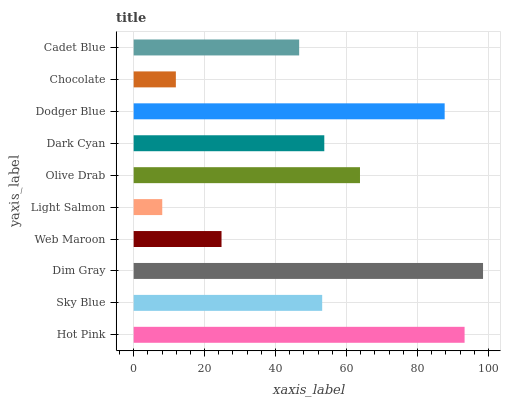Is Light Salmon the minimum?
Answer yes or no. Yes. Is Dim Gray the maximum?
Answer yes or no. Yes. Is Sky Blue the minimum?
Answer yes or no. No. Is Sky Blue the maximum?
Answer yes or no. No. Is Hot Pink greater than Sky Blue?
Answer yes or no. Yes. Is Sky Blue less than Hot Pink?
Answer yes or no. Yes. Is Sky Blue greater than Hot Pink?
Answer yes or no. No. Is Hot Pink less than Sky Blue?
Answer yes or no. No. Is Dark Cyan the high median?
Answer yes or no. Yes. Is Sky Blue the low median?
Answer yes or no. Yes. Is Olive Drab the high median?
Answer yes or no. No. Is Cadet Blue the low median?
Answer yes or no. No. 